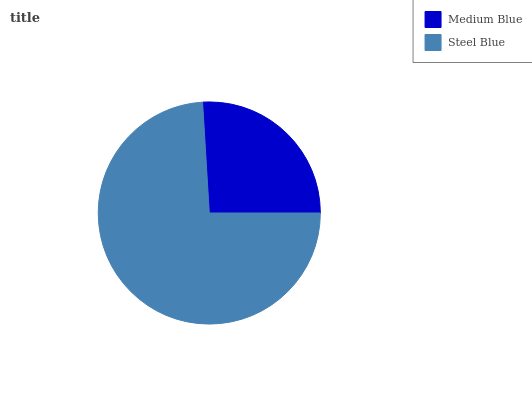Is Medium Blue the minimum?
Answer yes or no. Yes. Is Steel Blue the maximum?
Answer yes or no. Yes. Is Steel Blue the minimum?
Answer yes or no. No. Is Steel Blue greater than Medium Blue?
Answer yes or no. Yes. Is Medium Blue less than Steel Blue?
Answer yes or no. Yes. Is Medium Blue greater than Steel Blue?
Answer yes or no. No. Is Steel Blue less than Medium Blue?
Answer yes or no. No. Is Steel Blue the high median?
Answer yes or no. Yes. Is Medium Blue the low median?
Answer yes or no. Yes. Is Medium Blue the high median?
Answer yes or no. No. Is Steel Blue the low median?
Answer yes or no. No. 